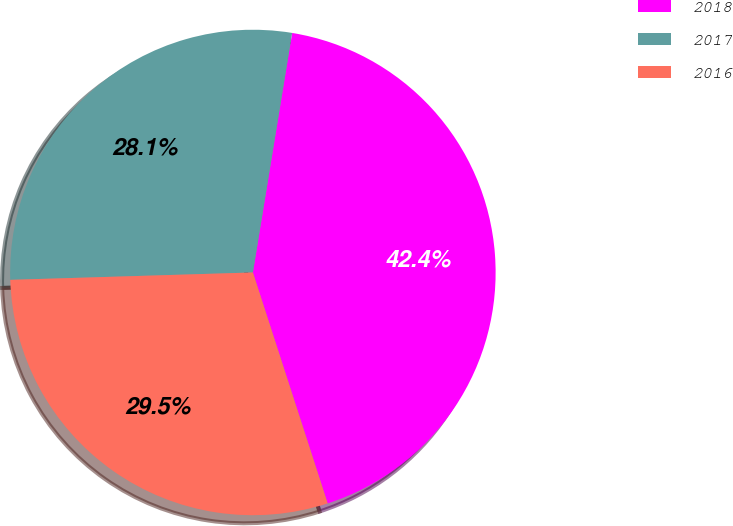<chart> <loc_0><loc_0><loc_500><loc_500><pie_chart><fcel>2018<fcel>2017<fcel>2016<nl><fcel>42.43%<fcel>28.07%<fcel>29.5%<nl></chart> 